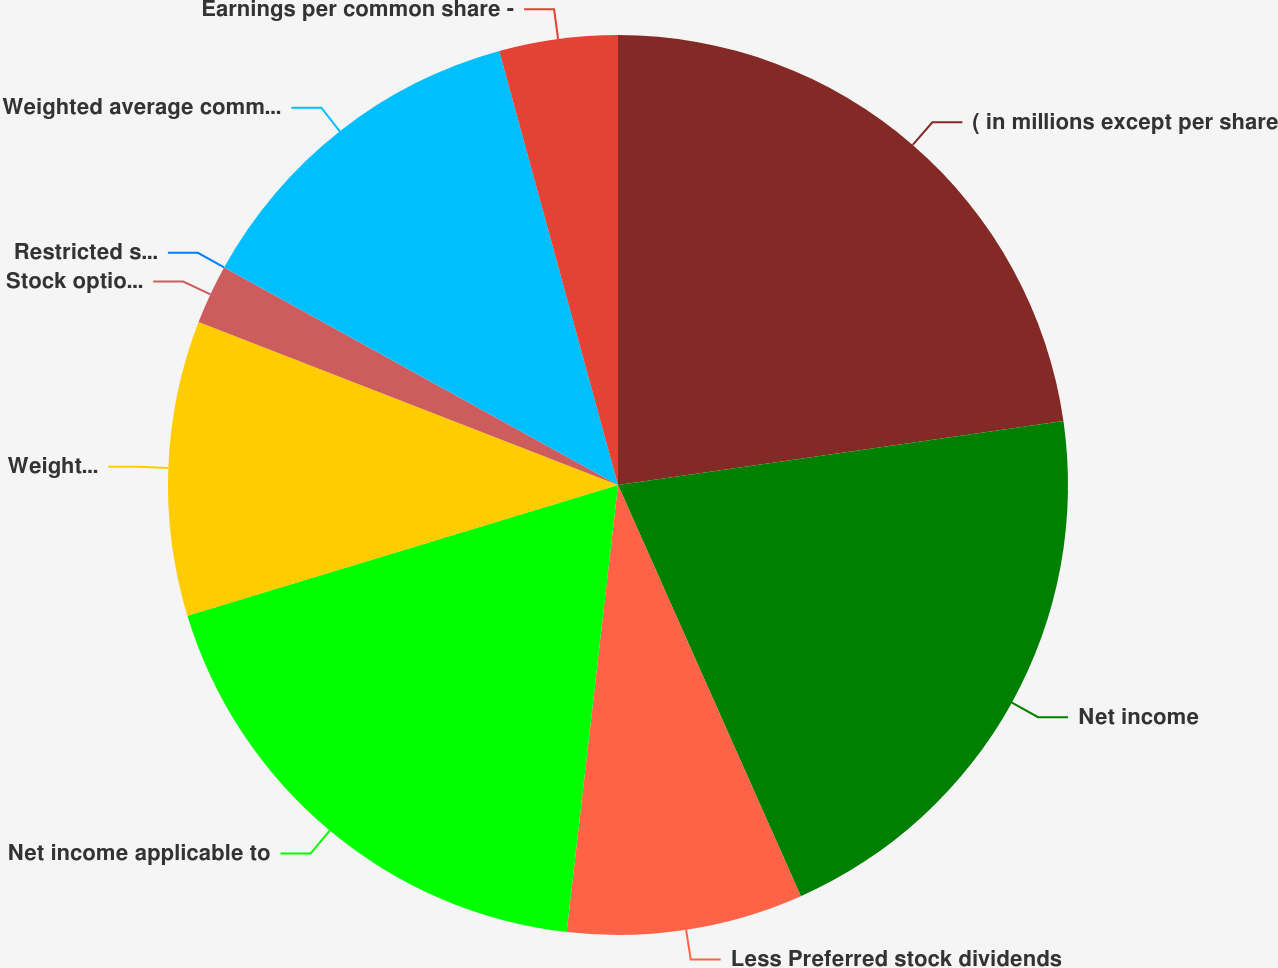<chart> <loc_0><loc_0><loc_500><loc_500><pie_chart><fcel>( in millions except per share<fcel>Net income<fcel>Less Preferred stock dividends<fcel>Net income applicable to<fcel>Weighted average common shares<fcel>Stock options<fcel>Restricted stock units<fcel>Weighted average common and<fcel>Earnings per common share -<nl><fcel>22.73%<fcel>20.61%<fcel>8.48%<fcel>18.49%<fcel>10.59%<fcel>2.13%<fcel>0.01%<fcel>12.71%<fcel>4.25%<nl></chart> 